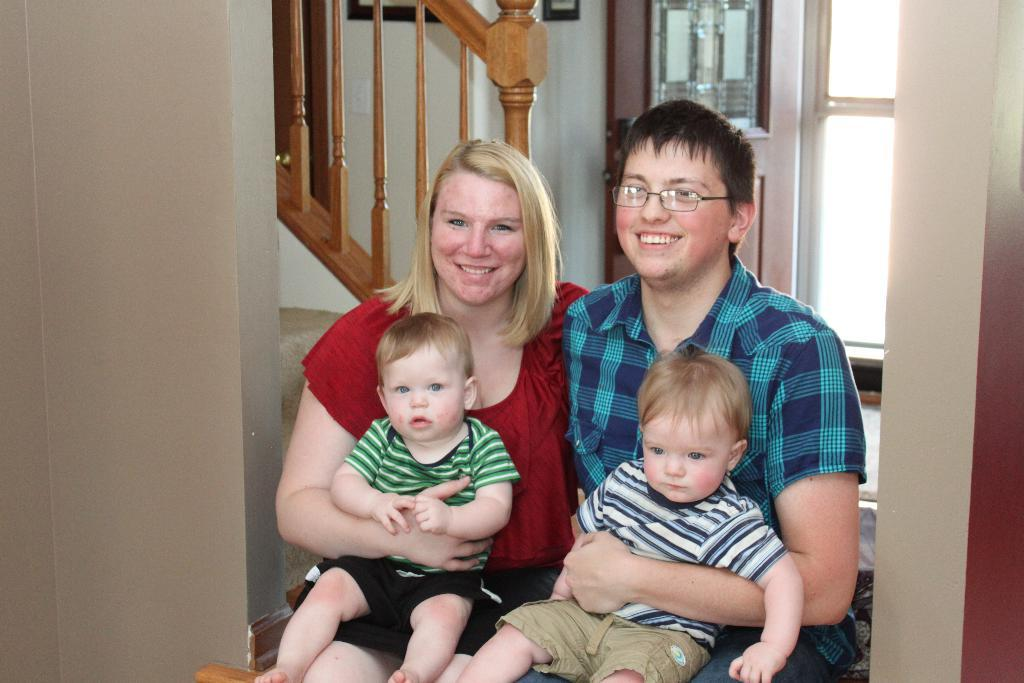How many people are present in the image? There are two people, a man and a woman, present in the image. What are the man and woman doing in the image? The man and woman are sitting and holding children on their laps. What can be seen in the background of the image? There is a staircase, railings, walls, and a door in the background of the image. What type of food is being served on the coast in the image? There is no coast or food present in the image; it features a man and woman sitting with children on their laps, and a background with a staircase, railings, walls, and a door. How many spiders are crawling on the railings in the image? There are no spiders present in the image; it features a man and woman sitting with children on their laps, and a background with a staircase, railings, walls, and a door. 